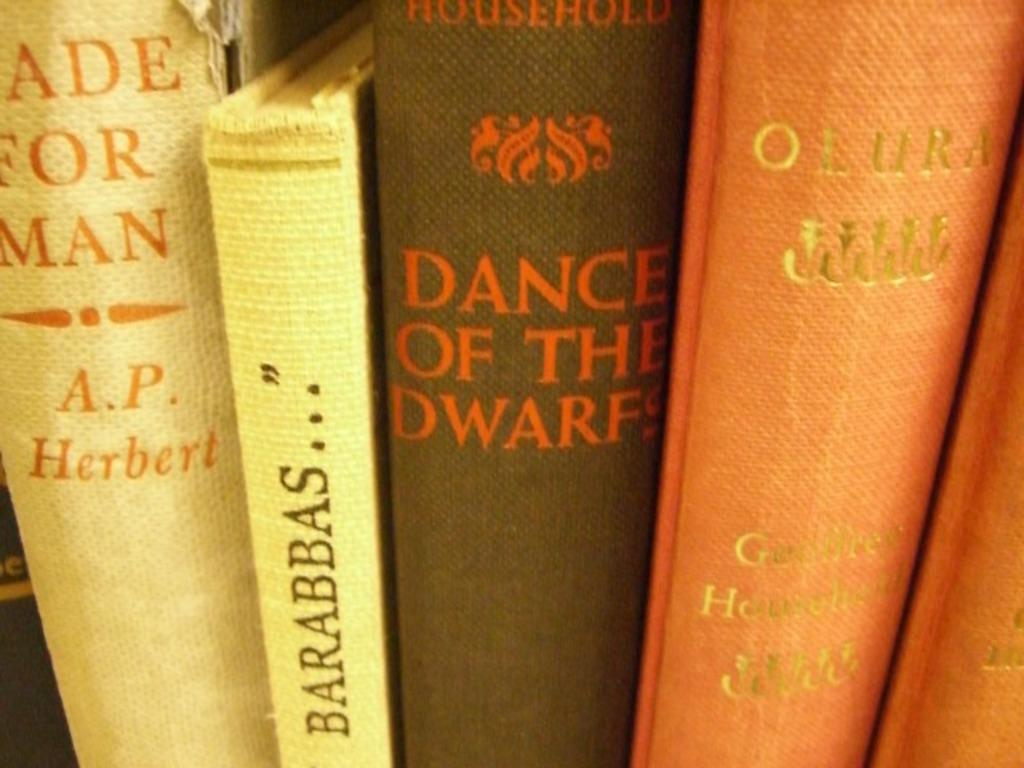<image>
Offer a succinct explanation of the picture presented. a row of books with one of them that says 'dance of the dwarfs' on the spine 